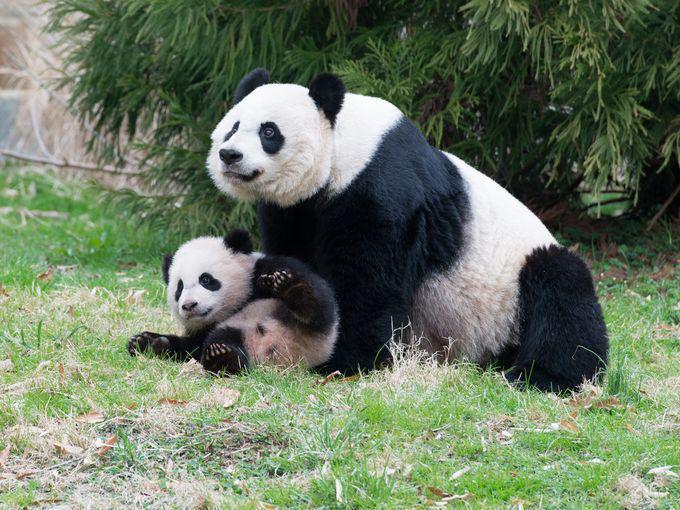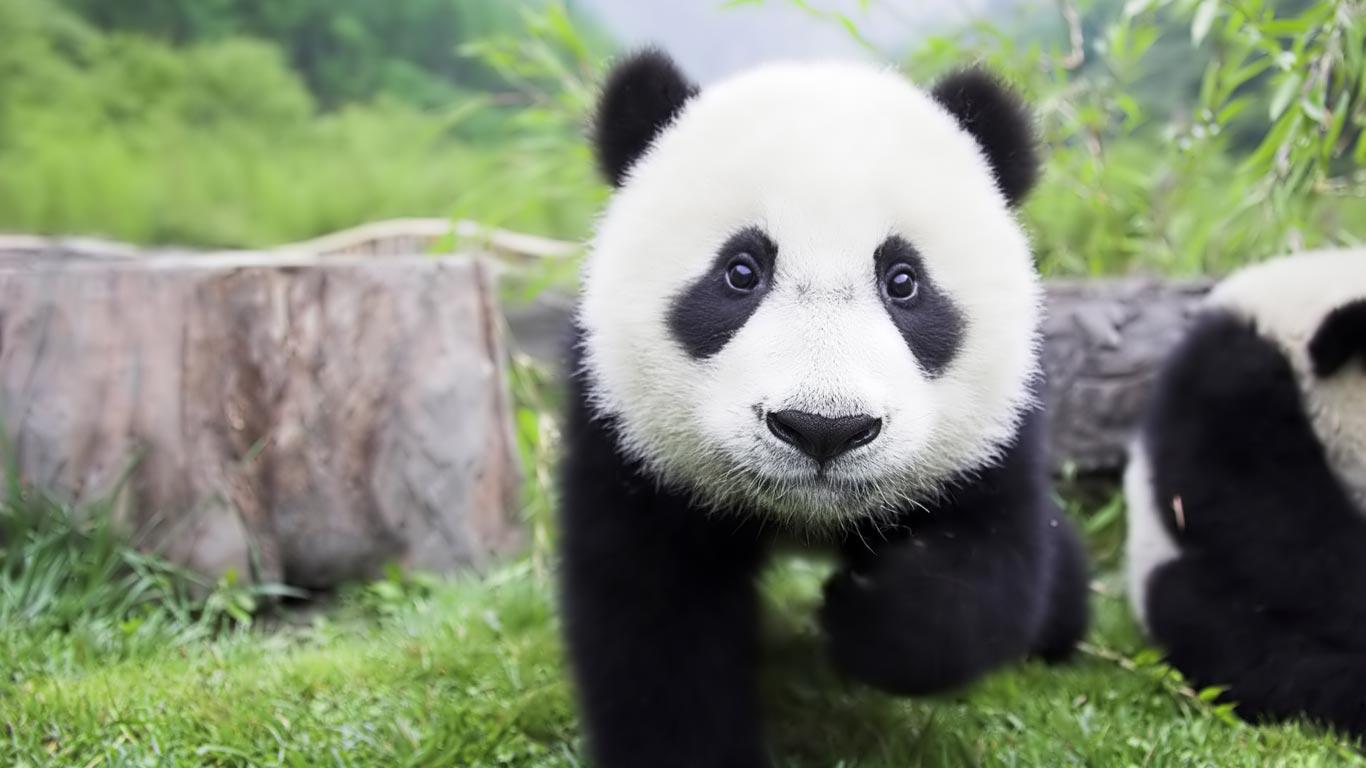The first image is the image on the left, the second image is the image on the right. For the images shown, is this caption "a mother panda is with her infant on the grass" true? Answer yes or no. Yes. 